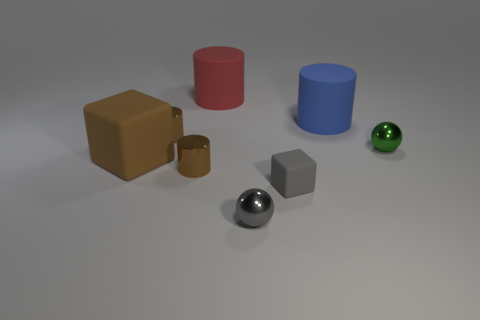What objects are depicted in the image? The image contains a variety of geometric shapes including a brown cube, a red cylinder, a blue cylinder, a small gold cylinder, a gray cube, a glossy black sphere, and a small green sphere. 